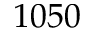<formula> <loc_0><loc_0><loc_500><loc_500>1 0 5 0</formula> 